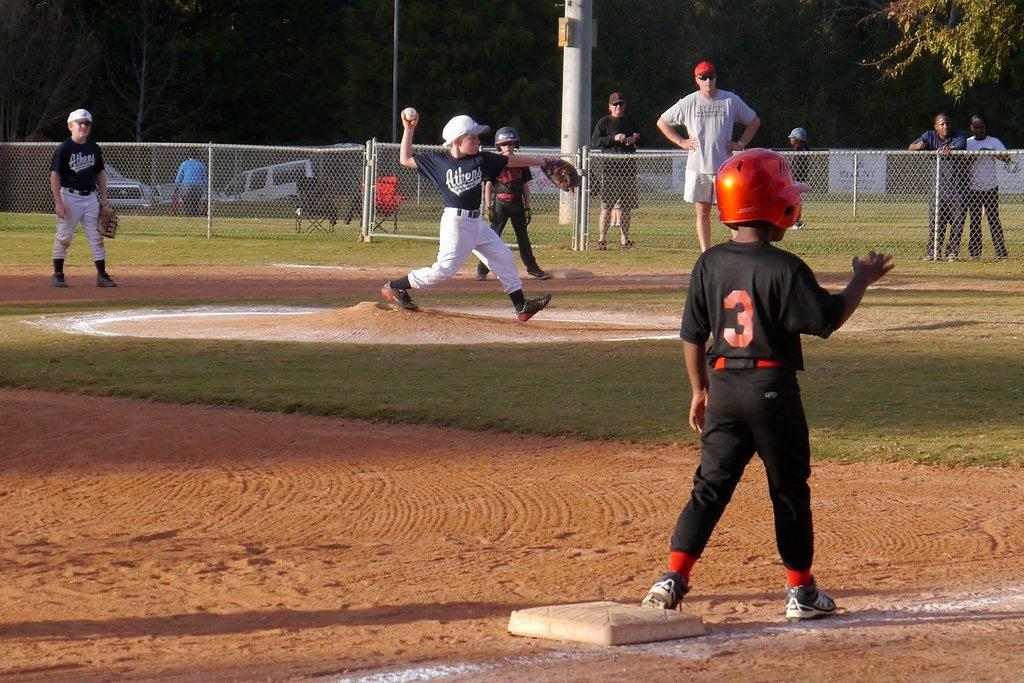<image>
Provide a brief description of the given image. a player that has the number 3 on the back of their shirt 